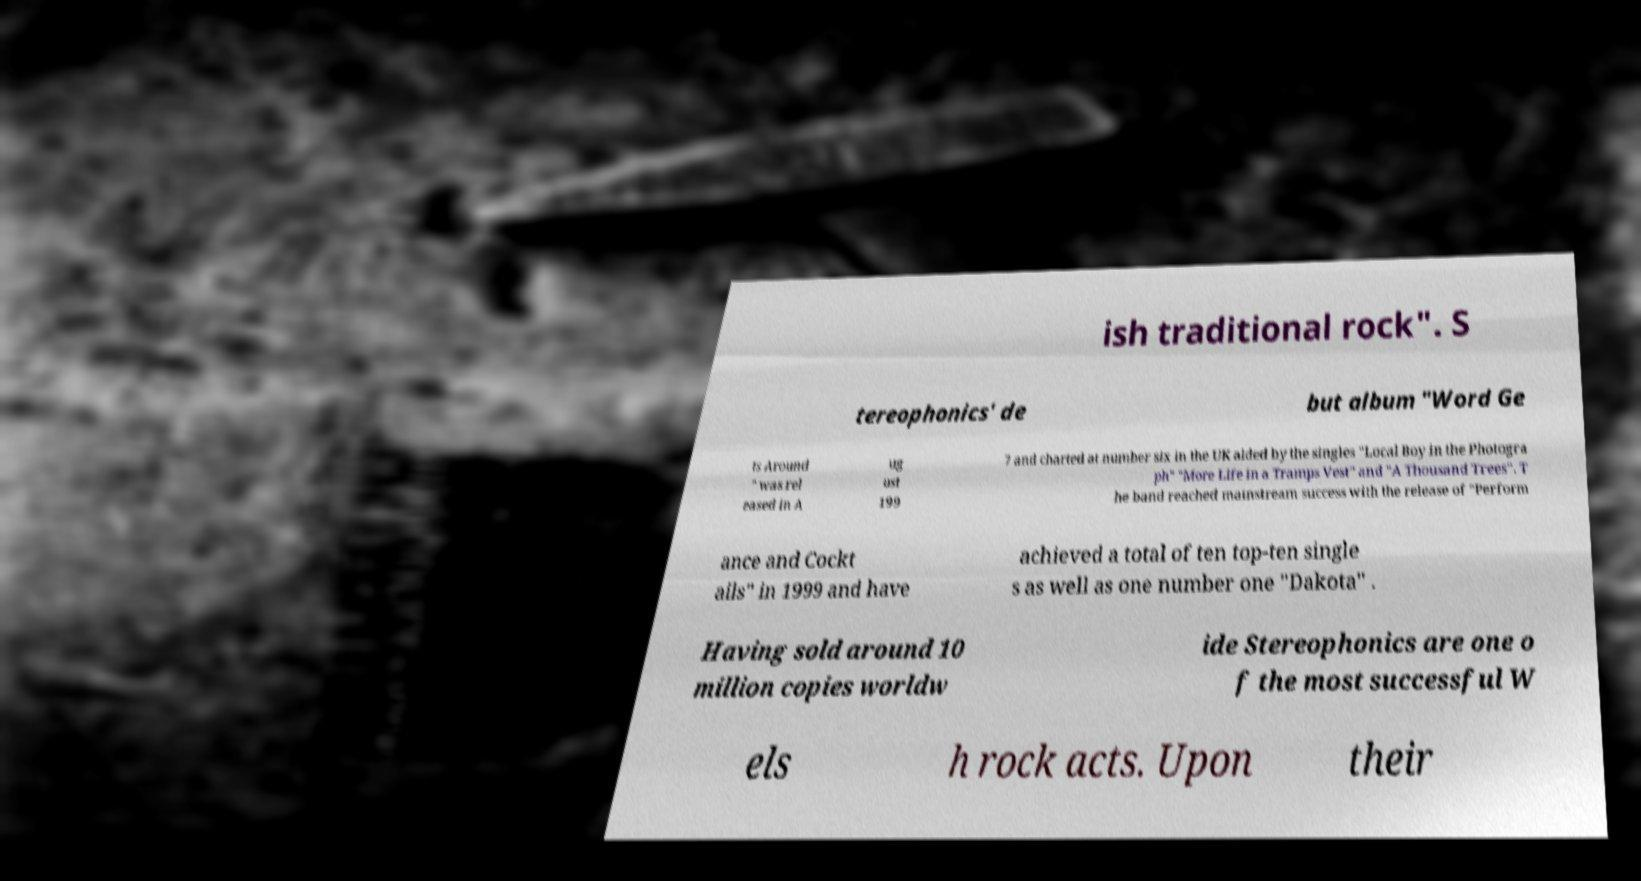I need the written content from this picture converted into text. Can you do that? ish traditional rock". S tereophonics' de but album "Word Ge ts Around " was rel eased in A ug ust 199 7 and charted at number six in the UK aided by the singles "Local Boy in the Photogra ph" "More Life in a Tramps Vest" and "A Thousand Trees". T he band reached mainstream success with the release of "Perform ance and Cockt ails" in 1999 and have achieved a total of ten top-ten single s as well as one number one "Dakota" . Having sold around 10 million copies worldw ide Stereophonics are one o f the most successful W els h rock acts. Upon their 